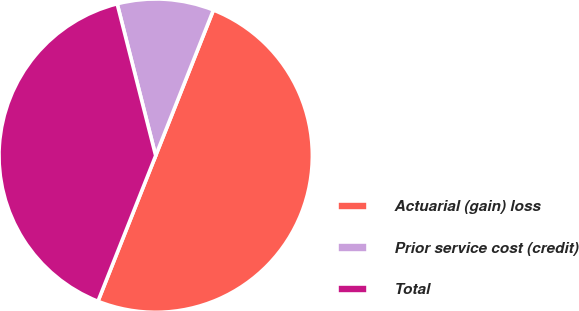Convert chart to OTSL. <chart><loc_0><loc_0><loc_500><loc_500><pie_chart><fcel>Actuarial (gain) loss<fcel>Prior service cost (credit)<fcel>Total<nl><fcel>50.0%<fcel>9.96%<fcel>40.04%<nl></chart> 